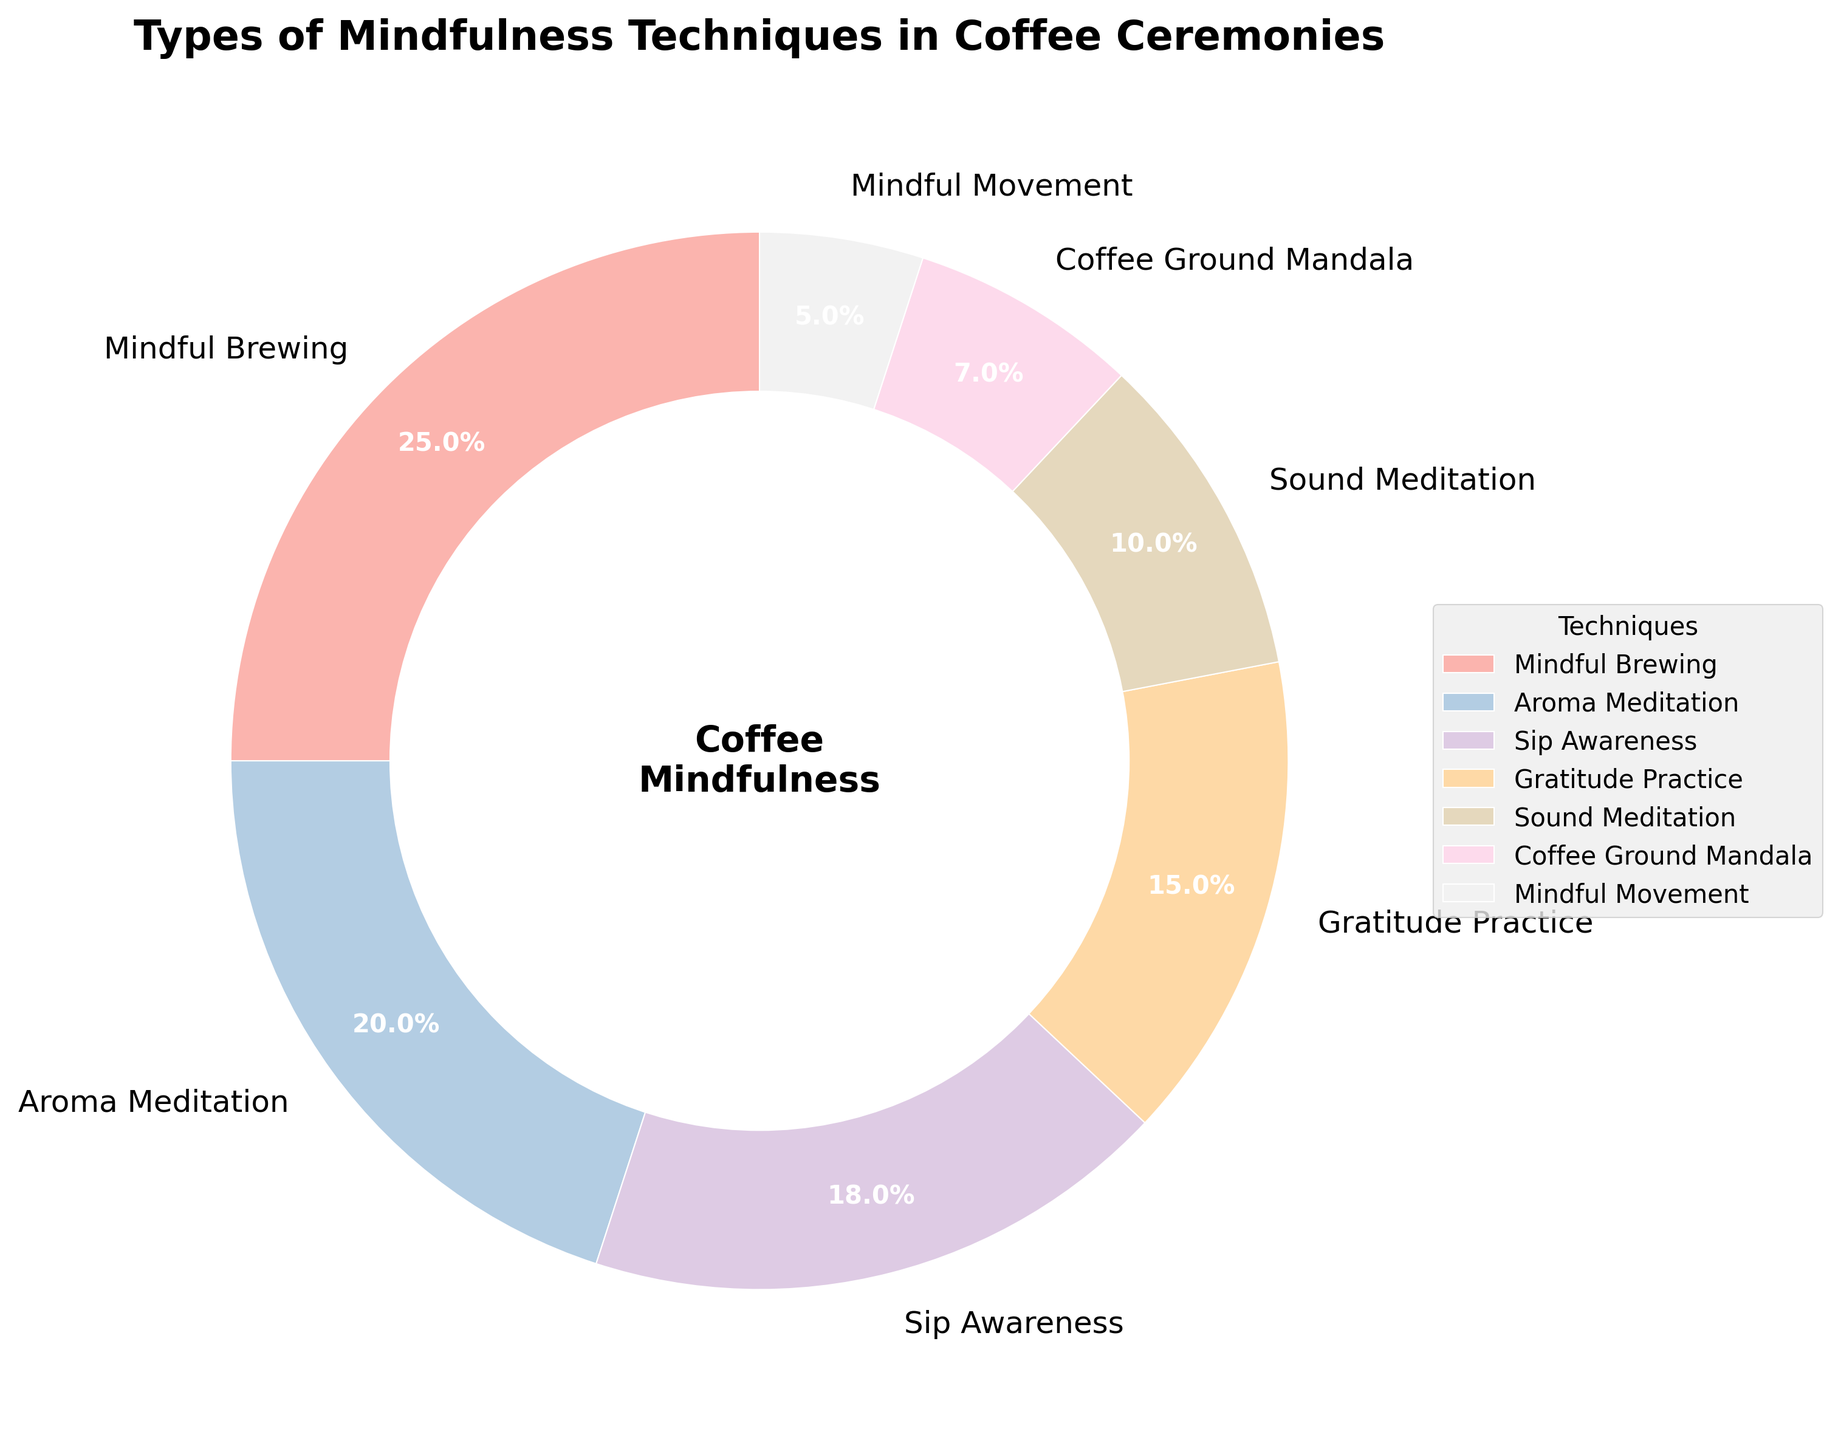Which mindfulness technique has the highest percentage in the pie chart? To determine this, look at the technique with the largest slice in the pie chart. The Mindful Brewing slice is represented as the largest portion with 25%.
Answer: Mindful Brewing Which two mindfulness techniques combined make up the smallest percentage? Add up the percentages of the two smallest slices. Coffee Ground Mandala is 7% and Mindful Movement is 5%, totaling 12%.
Answer: Coffee Ground Mandala and Mindful Movement What is the percentage difference between Aroma Meditation and Sip Awareness? Subtract Sip Awareness's percentage from Aroma Meditation's percentage: 20% - 18% = 2%.
Answer: 2% How much more popular is Gratitude Practice compared to Sound Meditation? Subtract Sound Meditation's percentage from Gratitude Practice's percentage: 15% - 10% = 5%.
Answer: 5% What is the sum of the percentages for Sip Awareness, Gratitude Practice, and Sound Meditation? Add the percentages of Sip Awareness, Gratitude Practice, and Sound Meditation: 18% + 15% + 10% = 43%.
Answer: 43% How does the popularity of Mindful Brewing compare to the combined percentage of Coffee Ground Mandala and Mindful Movement? Calculate the combined percentage of Coffee Ground Mandala and Mindful Movement: 7% + 5% = 12%. Then compare this to Mindful Brewing at 25%. Mindful Brewing is more popular.
Answer: Mindful Brewing is more popular What is the visual color representation of the category with the lowest percentage? Identify the color for the smallest slice; Mindful Movement has the least percentage at 5%. The color is a pastel shade as indicated by the palette used.
Answer: Pastel color (Mindful Movement slice) Which mindfulness technique is represented by the second-largest slice, and what is its percentage? Observe the second largest slice in the pie chart, which is Aroma Meditation, listed at 20%.
Answer: Aroma Meditation, 20% What proportion of the chart is taken up by techniques with less than 10% each? Sum the percentages of Coffee Ground Mandala and Mindful Movement: 7% + 5% = 12%.
Answer: 12% Which category is more visually prominent, Sound Meditation or Sip Awareness, and by how much? Compare the percentages directly: Sip Awareness is 18% and Sound Meditation is 10%. The difference is 18% - 10% = 8%.
Answer: Sip Awareness, by 8% 